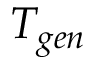Convert formula to latex. <formula><loc_0><loc_0><loc_500><loc_500>T _ { g e n }</formula> 